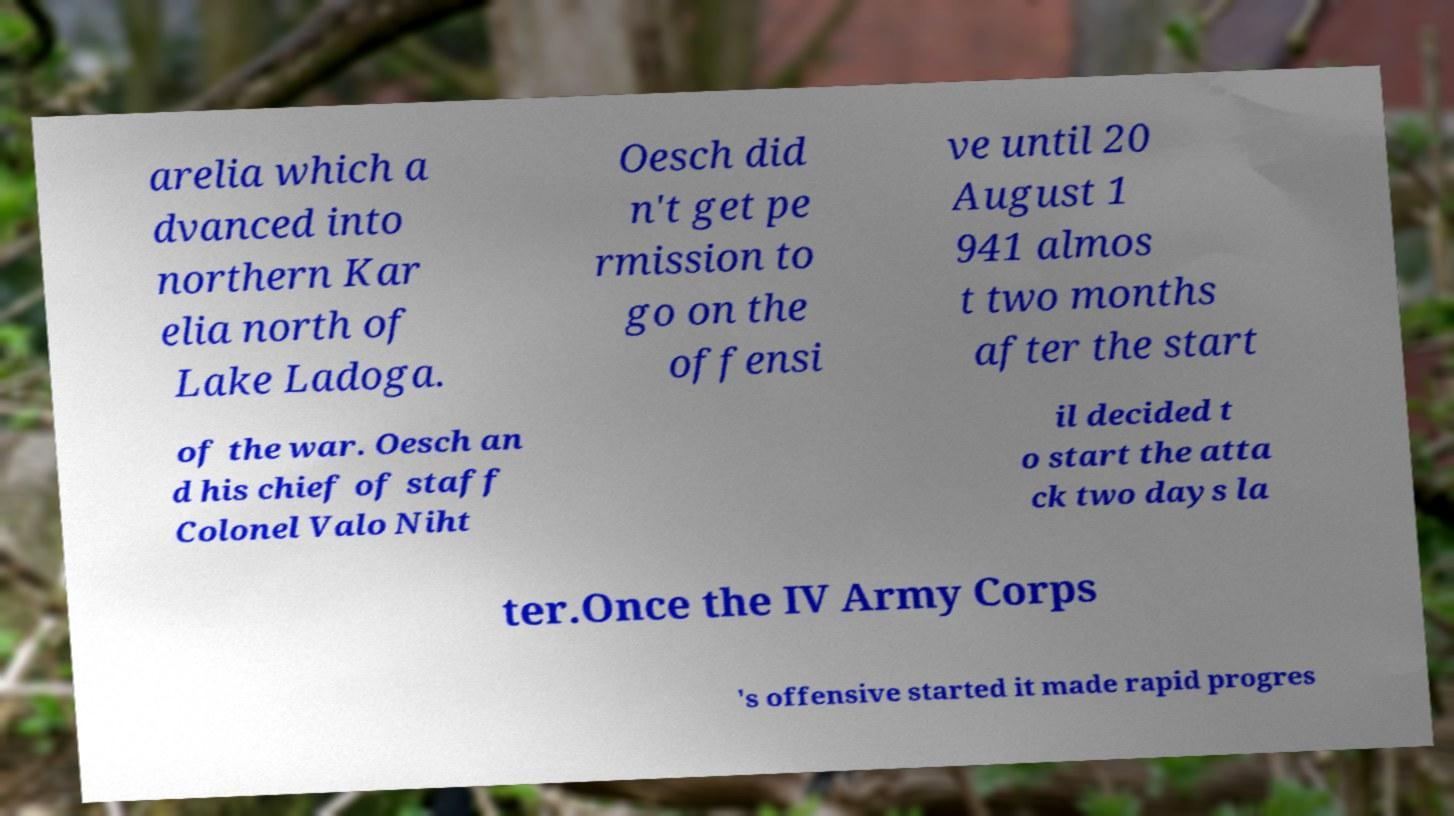Please read and relay the text visible in this image. What does it say? arelia which a dvanced into northern Kar elia north of Lake Ladoga. Oesch did n't get pe rmission to go on the offensi ve until 20 August 1 941 almos t two months after the start of the war. Oesch an d his chief of staff Colonel Valo Niht il decided t o start the atta ck two days la ter.Once the IV Army Corps 's offensive started it made rapid progres 